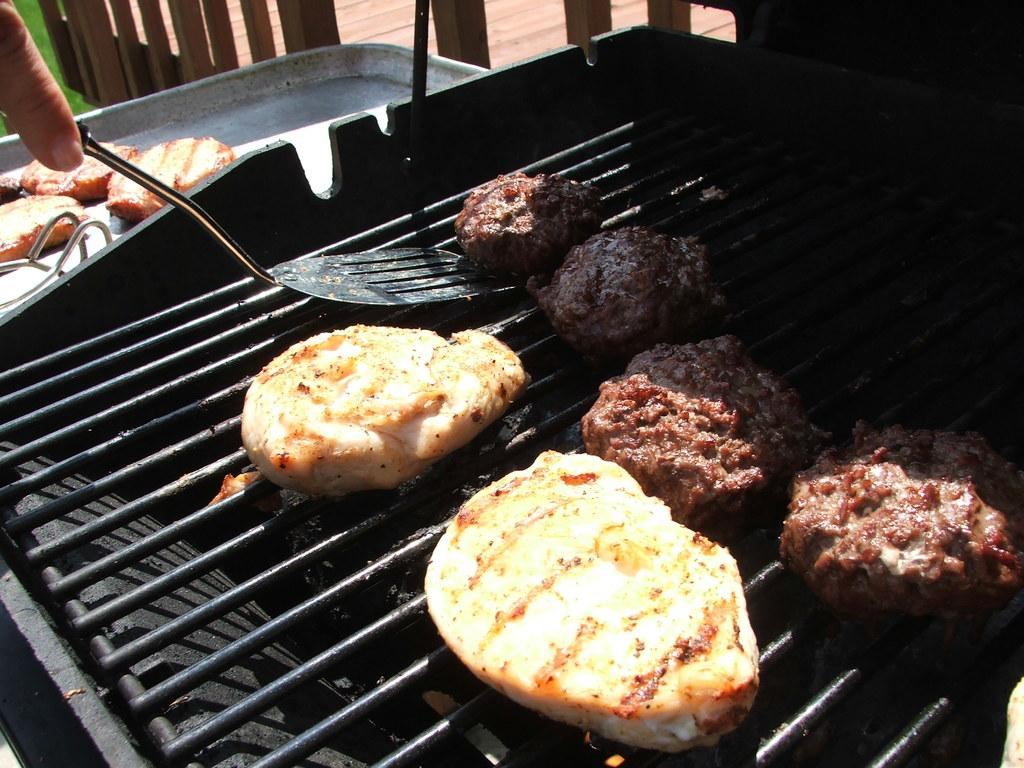What is being cooked on the grill in the image? There is food on the grill in the image. Who is holding a serving spoon in the image? A person is holding a serving spoon in the image. What is in the tray in the image? There is food in a tray in the image. What type of seating can be seen in the background of the image? There appear to be wooden chairs in the background of the image. What type of soup is being served in the image? There is no soup present in the image; it features food on a grill, a serving spoon, food in a tray, and wooden chairs in the background. Can you describe the motion of the person jumping in the image? There is no person jumping in the image; the person holding the serving spoon is stationary. 